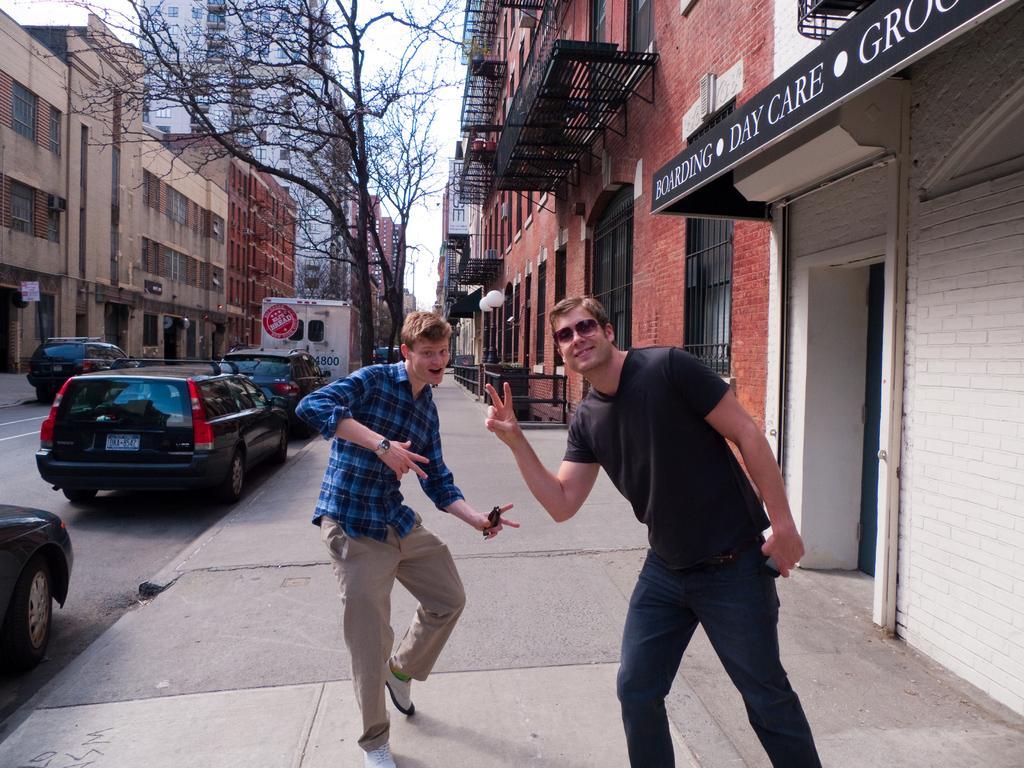How would you summarize this image in a sentence or two? In this picture we can see vehicles on the road, two men standing on a footpath and smiling, goggles, buildings with windows, trees, name board, lights, walls and in the background we can see the sky. 